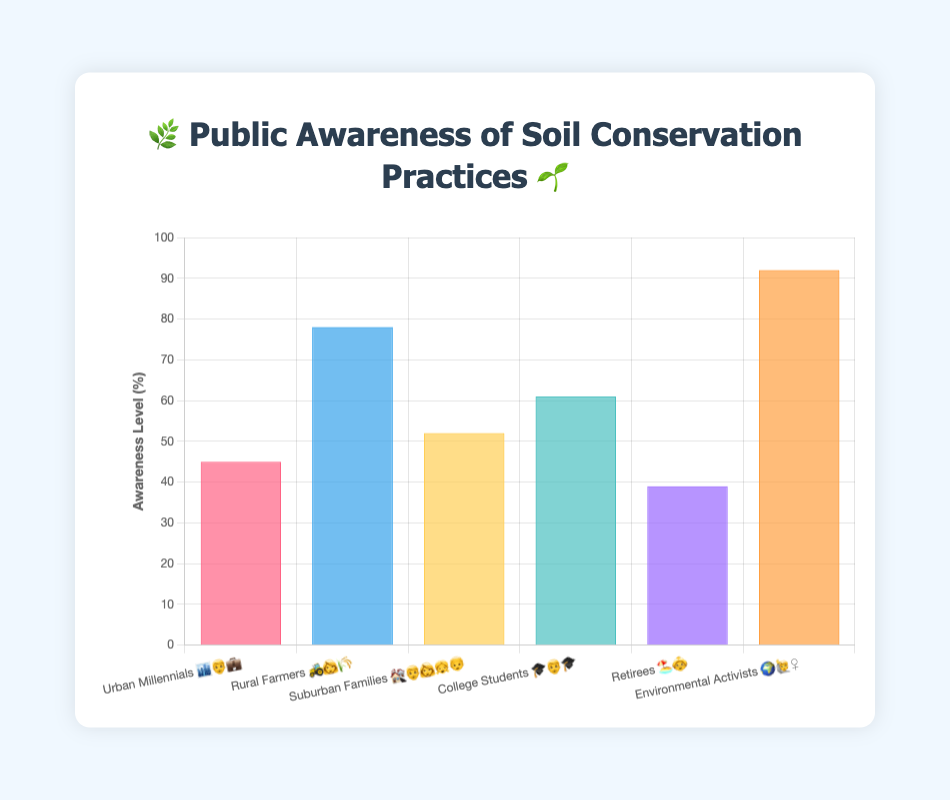Which group has the highest awareness level? The Environmental Activists group has the highest bar, indicating the highest awareness level of soil conservation practices at 92%.
Answer: Environmental Activists 🌍🙋‍♀️ What's the awareness level of Urban Millennials? The chart shows that the bar for Urban Millennials 🏙️👨‍💼 reaches up to 45%, which indicates their awareness level.
Answer: 45% How many groups have an awareness level above 50%? By observing the chart, we see that Rural Farmers 🚜👩‍🌾 (78%), Suburban Families 🏘️👨‍👩‍👧‍👦 (52%), College Students 🎓👨‍🎓 (61%), and Environmental Activists 🌍🙋‍♀️ (92%) all have awareness levels above 50%. Therefore, there are four groups with an awareness level above 50%.
Answer: 4 What's the difference in awareness level between Rural Farmers and Retirees? The awareness level of Rural Farmers 🚜👩‍🌾 is 78%, and for Retirees 🏖️👵, it is 39%. The difference is 78% - 39% = 39%.
Answer: 39% Which group has the lowest awareness level? By looking at the shortest bar, we see that the Retirees 🏖️👵 group has the lowest awareness level at 39%.
Answer: Retirees 🏖️👵 What is the average awareness level across all groups? Sum up all awareness levels (45 + 78 + 52 + 61 + 39 + 92) = 367, then divide by the number of groups (6). The average awareness level is 367 / 6 ≈ 61.17%.
Answer: 61.17% How much higher is the awareness level of Environmental Activists compared to College Students? The Environmental Activists 🌍🙋‍♀️ have an awareness level of 92%, and the College Students 🎓👨‍🎓 have 61%. The difference is 92% - 61% = 31%.
Answer: 31% Which demographic group has an awareness level closest to the average awareness level? The average awareness level is approximately 61.17%. The College Students 🎓👨‍🎓 have an awareness level of 61%, which is the closest to the average.
Answer: College Students 🎓👨‍🎓 